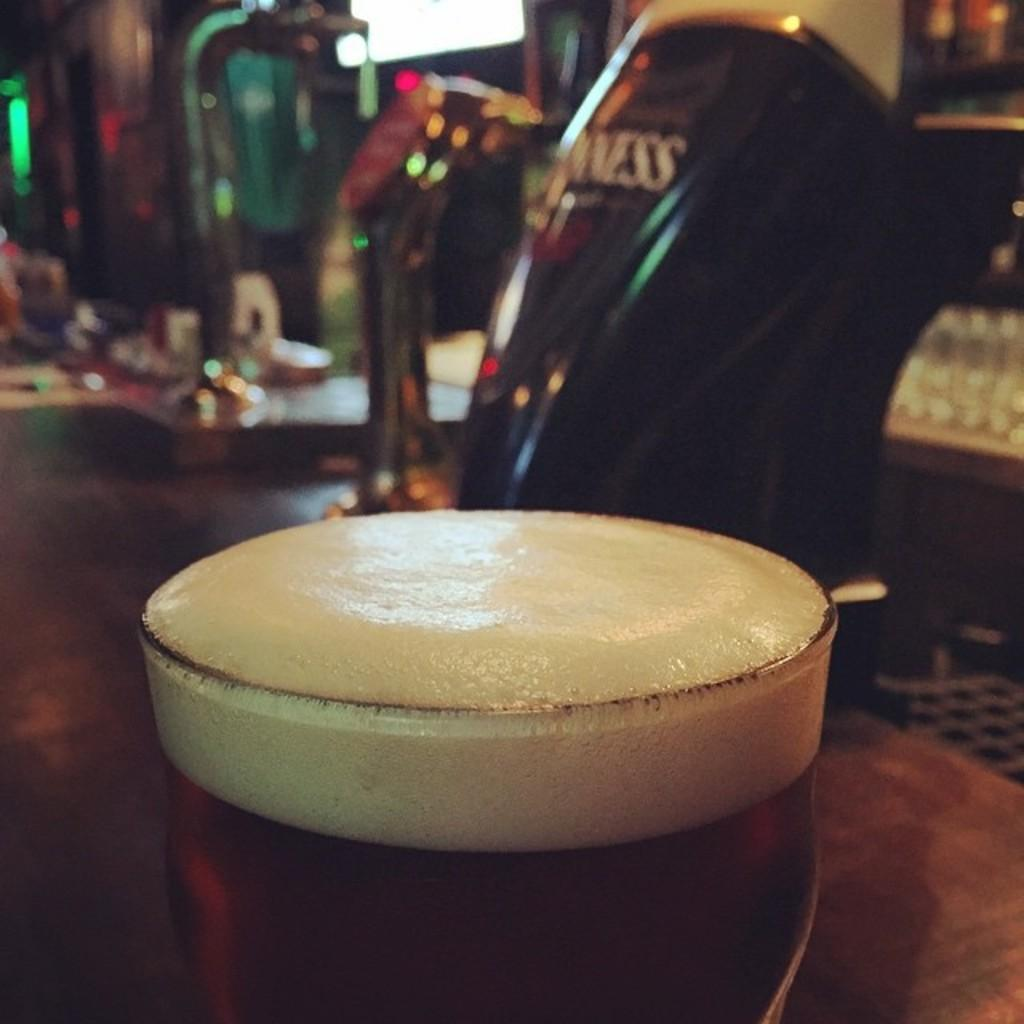What is in the glass that is visible in the image? There is a glass of liquid with foam in the image. What is the glass placed on? The glass is on a wooden surface. What can be seen behind the glass in the image? There are objects visible behind the glass. How would you describe the background of the image? The background of the image is blurred. What type of pie is being served on the airplane in the image? There is no airplane or pie present in the image; it features a glass of liquid with foam on a wooden surface. 